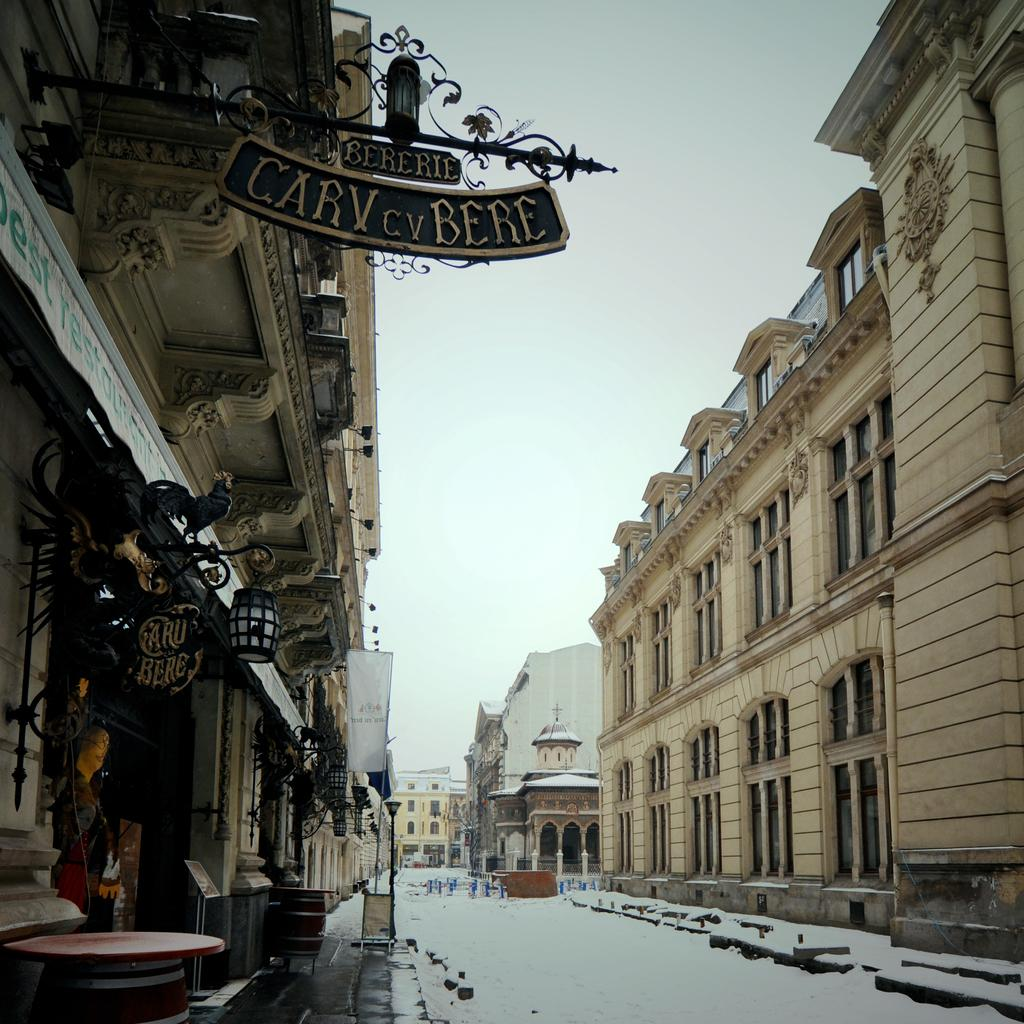What is the condition of the roads in the image? The roads in the image are covered with snow. What type of structures can be seen in the image? There are buildings in the image. What artistic elements are present in the image? Sculptures are present in the image. What signage is visible in the image? Name boards are visible in the image. What type of lighting is present in the image? Street lights are in the image. What type of waste disposal units are present in the image? Bins are present in the image. What type of vegetation is visible in the image? Trees are visible in the image. What part of the natural environment is visible in the image? The sky is visible in the image. What type of power source is visible in the image? There is no power source visible in the image. What type of hydrant is present in the image? There is no hydrant present in the image. 